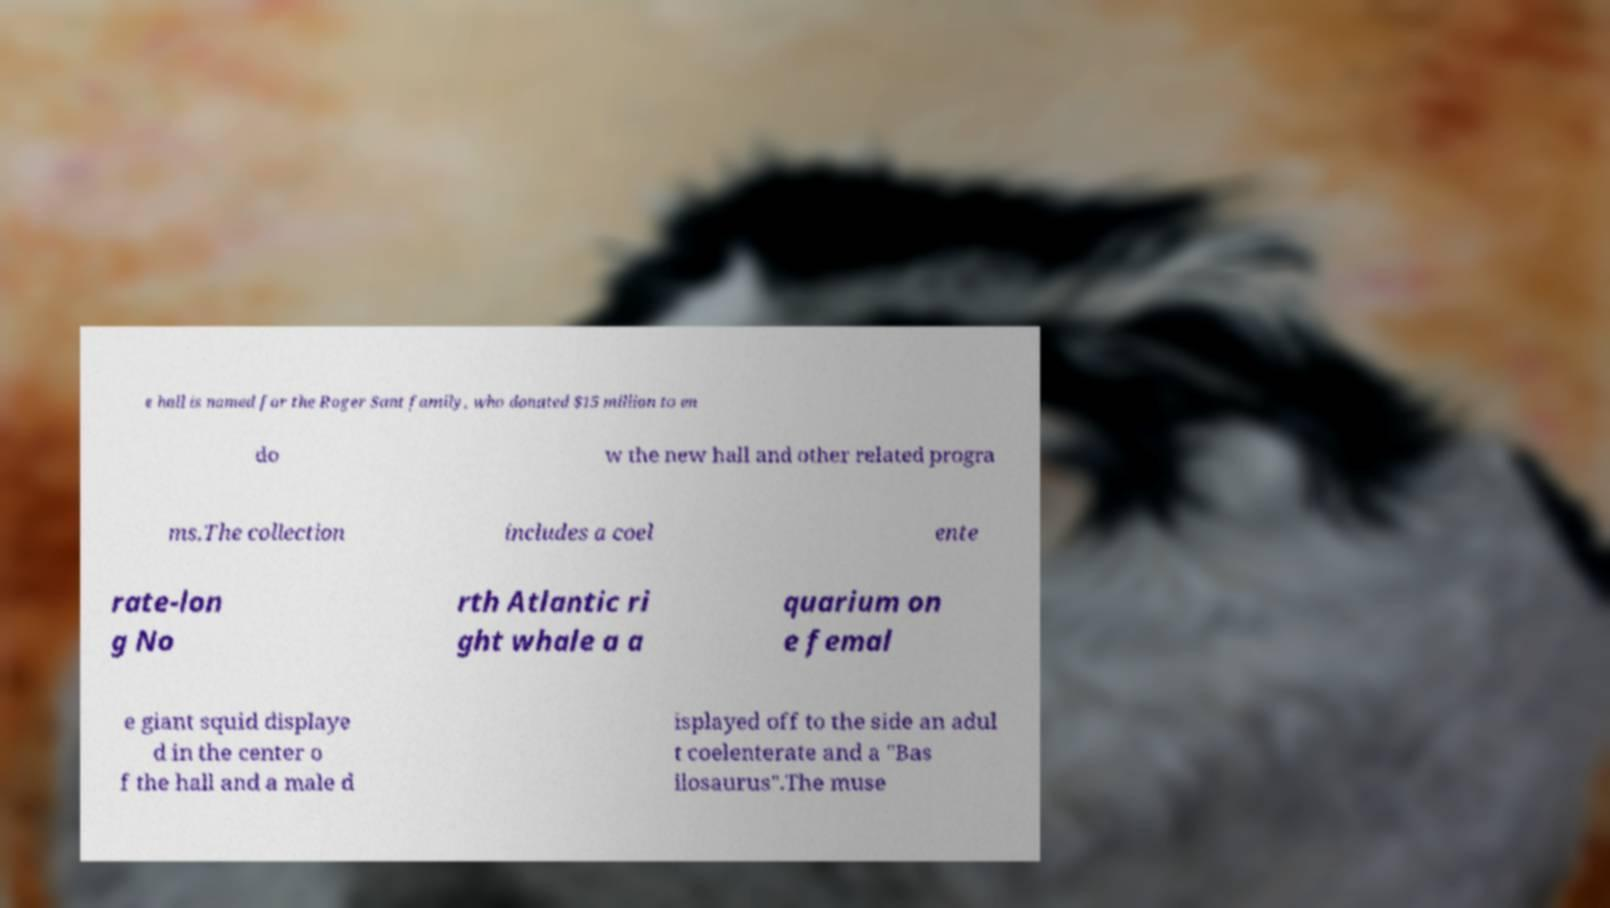Can you read and provide the text displayed in the image?This photo seems to have some interesting text. Can you extract and type it out for me? e hall is named for the Roger Sant family, who donated $15 million to en do w the new hall and other related progra ms.The collection includes a coel ente rate-lon g No rth Atlantic ri ght whale a a quarium on e femal e giant squid displaye d in the center o f the hall and a male d isplayed off to the side an adul t coelenterate and a "Bas ilosaurus".The muse 